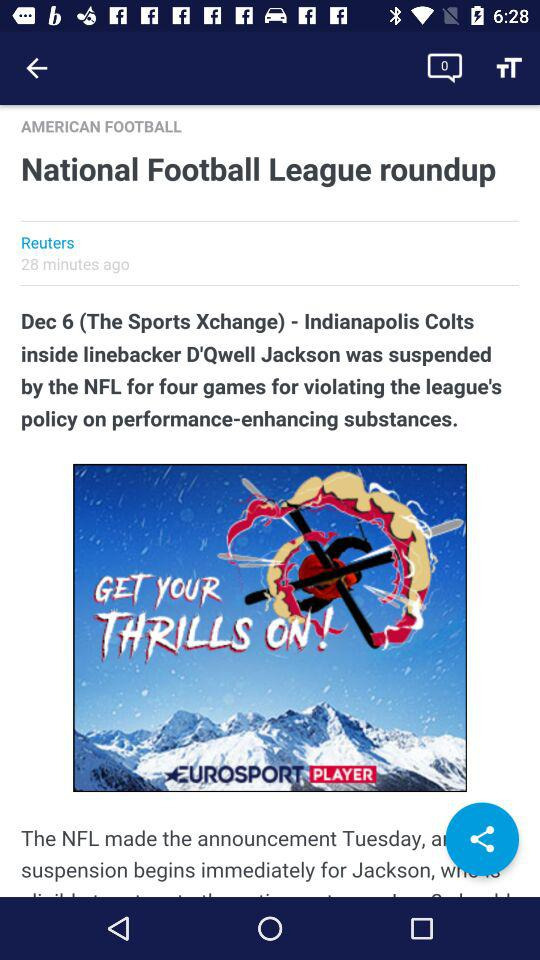How many minutes ago was the post posted? The post was posted 28 minutes ago. 